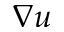Convert formula to latex. <formula><loc_0><loc_0><loc_500><loc_500>\nabla u</formula> 